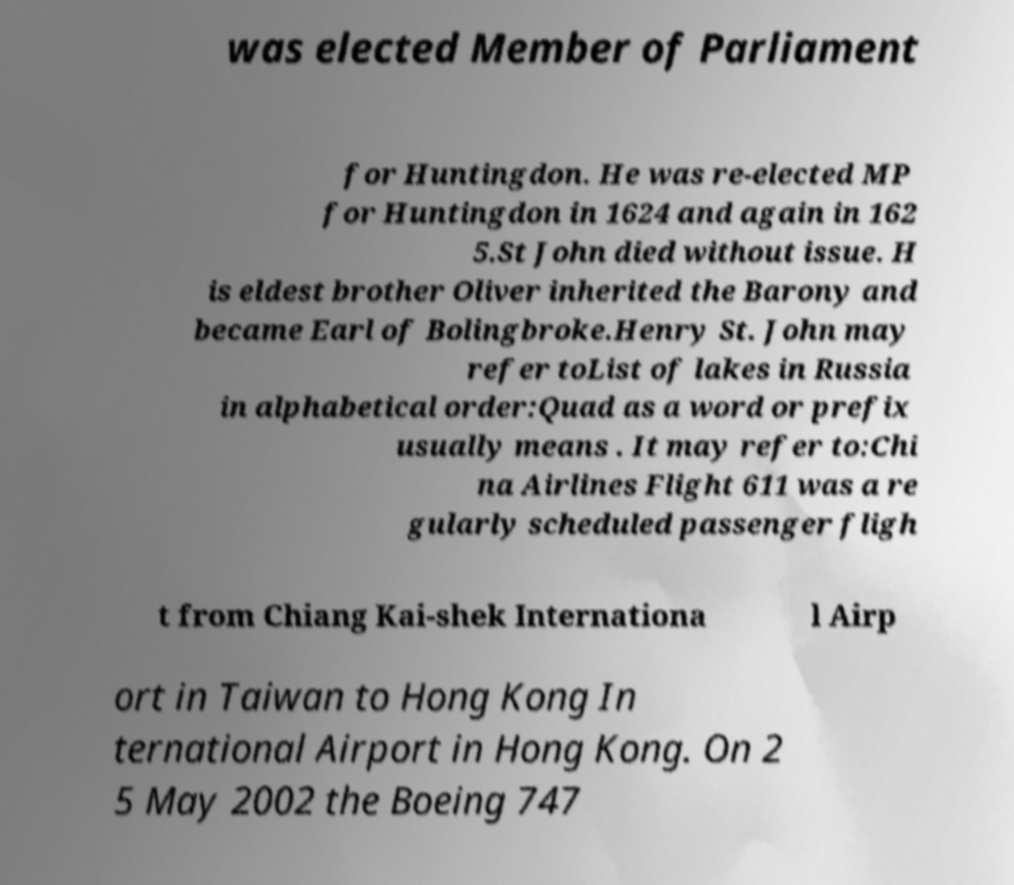Can you accurately transcribe the text from the provided image for me? was elected Member of Parliament for Huntingdon. He was re-elected MP for Huntingdon in 1624 and again in 162 5.St John died without issue. H is eldest brother Oliver inherited the Barony and became Earl of Bolingbroke.Henry St. John may refer toList of lakes in Russia in alphabetical order:Quad as a word or prefix usually means . It may refer to:Chi na Airlines Flight 611 was a re gularly scheduled passenger fligh t from Chiang Kai-shek Internationa l Airp ort in Taiwan to Hong Kong In ternational Airport in Hong Kong. On 2 5 May 2002 the Boeing 747 